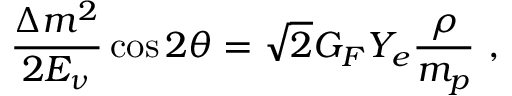<formula> <loc_0><loc_0><loc_500><loc_500>\frac { \Delta m ^ { 2 } } { 2 E _ { \nu } } \cos 2 \theta = \sqrt { 2 } G _ { F } Y _ { e } \frac { \rho } { m _ { p } } \ ,</formula> 